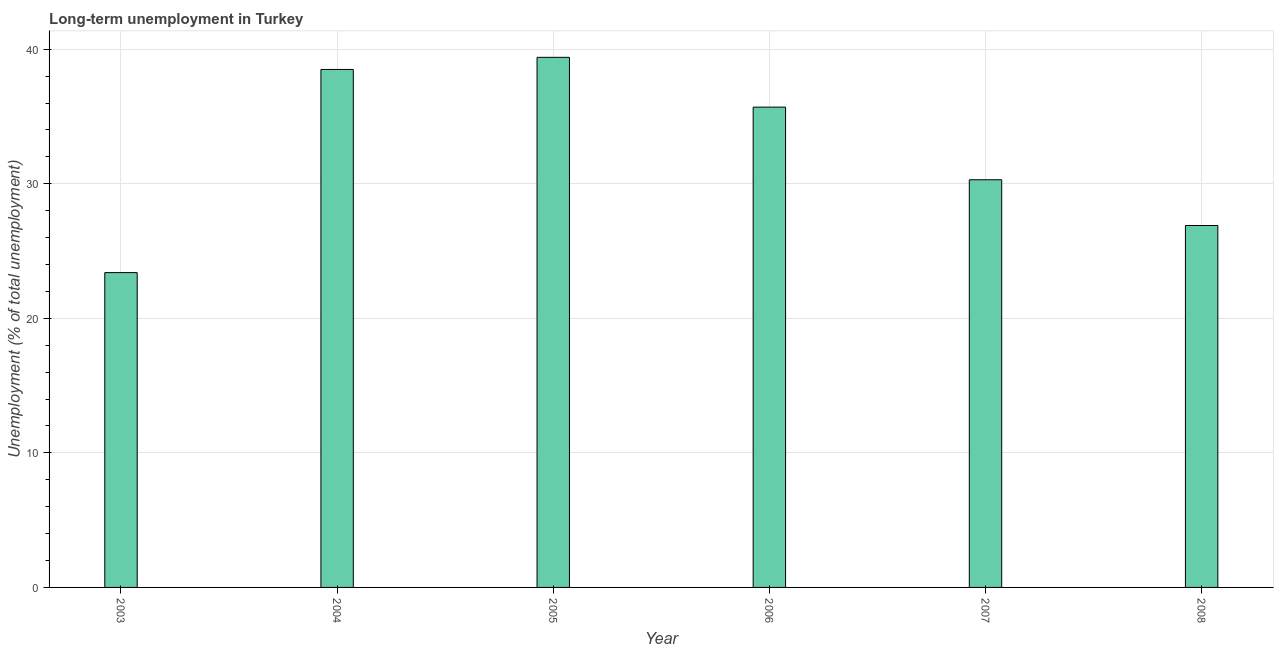What is the title of the graph?
Your answer should be compact. Long-term unemployment in Turkey. What is the label or title of the Y-axis?
Provide a succinct answer. Unemployment (% of total unemployment). What is the long-term unemployment in 2004?
Make the answer very short. 38.5. Across all years, what is the maximum long-term unemployment?
Keep it short and to the point. 39.4. Across all years, what is the minimum long-term unemployment?
Provide a short and direct response. 23.4. In which year was the long-term unemployment maximum?
Your answer should be compact. 2005. In which year was the long-term unemployment minimum?
Provide a succinct answer. 2003. What is the sum of the long-term unemployment?
Keep it short and to the point. 194.2. What is the difference between the long-term unemployment in 2003 and 2004?
Keep it short and to the point. -15.1. What is the average long-term unemployment per year?
Make the answer very short. 32.37. What is the median long-term unemployment?
Make the answer very short. 33. In how many years, is the long-term unemployment greater than 4 %?
Ensure brevity in your answer.  6. What is the ratio of the long-term unemployment in 2003 to that in 2005?
Provide a short and direct response. 0.59. Is the difference between the long-term unemployment in 2004 and 2007 greater than the difference between any two years?
Offer a terse response. No. In how many years, is the long-term unemployment greater than the average long-term unemployment taken over all years?
Your response must be concise. 3. How many bars are there?
Make the answer very short. 6. Are all the bars in the graph horizontal?
Provide a succinct answer. No. How many years are there in the graph?
Offer a very short reply. 6. What is the difference between two consecutive major ticks on the Y-axis?
Give a very brief answer. 10. What is the Unemployment (% of total unemployment) in 2003?
Offer a very short reply. 23.4. What is the Unemployment (% of total unemployment) in 2004?
Make the answer very short. 38.5. What is the Unemployment (% of total unemployment) of 2005?
Make the answer very short. 39.4. What is the Unemployment (% of total unemployment) of 2006?
Your answer should be compact. 35.7. What is the Unemployment (% of total unemployment) in 2007?
Offer a very short reply. 30.3. What is the Unemployment (% of total unemployment) in 2008?
Your answer should be very brief. 26.9. What is the difference between the Unemployment (% of total unemployment) in 2003 and 2004?
Provide a succinct answer. -15.1. What is the difference between the Unemployment (% of total unemployment) in 2003 and 2006?
Your answer should be very brief. -12.3. What is the difference between the Unemployment (% of total unemployment) in 2004 and 2005?
Offer a terse response. -0.9. What is the difference between the Unemployment (% of total unemployment) in 2005 and 2006?
Offer a terse response. 3.7. What is the difference between the Unemployment (% of total unemployment) in 2005 and 2007?
Your answer should be compact. 9.1. What is the difference between the Unemployment (% of total unemployment) in 2006 and 2007?
Your answer should be compact. 5.4. What is the ratio of the Unemployment (% of total unemployment) in 2003 to that in 2004?
Offer a very short reply. 0.61. What is the ratio of the Unemployment (% of total unemployment) in 2003 to that in 2005?
Provide a short and direct response. 0.59. What is the ratio of the Unemployment (% of total unemployment) in 2003 to that in 2006?
Make the answer very short. 0.66. What is the ratio of the Unemployment (% of total unemployment) in 2003 to that in 2007?
Keep it short and to the point. 0.77. What is the ratio of the Unemployment (% of total unemployment) in 2003 to that in 2008?
Ensure brevity in your answer.  0.87. What is the ratio of the Unemployment (% of total unemployment) in 2004 to that in 2005?
Provide a short and direct response. 0.98. What is the ratio of the Unemployment (% of total unemployment) in 2004 to that in 2006?
Keep it short and to the point. 1.08. What is the ratio of the Unemployment (% of total unemployment) in 2004 to that in 2007?
Give a very brief answer. 1.27. What is the ratio of the Unemployment (% of total unemployment) in 2004 to that in 2008?
Give a very brief answer. 1.43. What is the ratio of the Unemployment (% of total unemployment) in 2005 to that in 2006?
Ensure brevity in your answer.  1.1. What is the ratio of the Unemployment (% of total unemployment) in 2005 to that in 2008?
Your answer should be very brief. 1.47. What is the ratio of the Unemployment (% of total unemployment) in 2006 to that in 2007?
Give a very brief answer. 1.18. What is the ratio of the Unemployment (% of total unemployment) in 2006 to that in 2008?
Keep it short and to the point. 1.33. What is the ratio of the Unemployment (% of total unemployment) in 2007 to that in 2008?
Your answer should be compact. 1.13. 